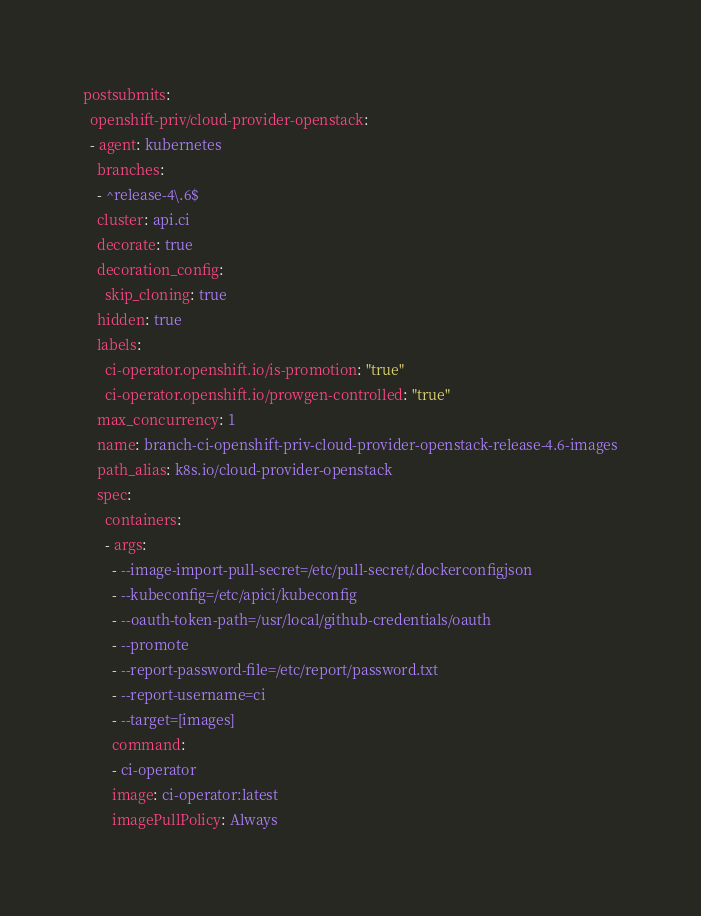<code> <loc_0><loc_0><loc_500><loc_500><_YAML_>postsubmits:
  openshift-priv/cloud-provider-openstack:
  - agent: kubernetes
    branches:
    - ^release-4\.6$
    cluster: api.ci
    decorate: true
    decoration_config:
      skip_cloning: true
    hidden: true
    labels:
      ci-operator.openshift.io/is-promotion: "true"
      ci-operator.openshift.io/prowgen-controlled: "true"
    max_concurrency: 1
    name: branch-ci-openshift-priv-cloud-provider-openstack-release-4.6-images
    path_alias: k8s.io/cloud-provider-openstack
    spec:
      containers:
      - args:
        - --image-import-pull-secret=/etc/pull-secret/.dockerconfigjson
        - --kubeconfig=/etc/apici/kubeconfig
        - --oauth-token-path=/usr/local/github-credentials/oauth
        - --promote
        - --report-password-file=/etc/report/password.txt
        - --report-username=ci
        - --target=[images]
        command:
        - ci-operator
        image: ci-operator:latest
        imagePullPolicy: Always</code> 